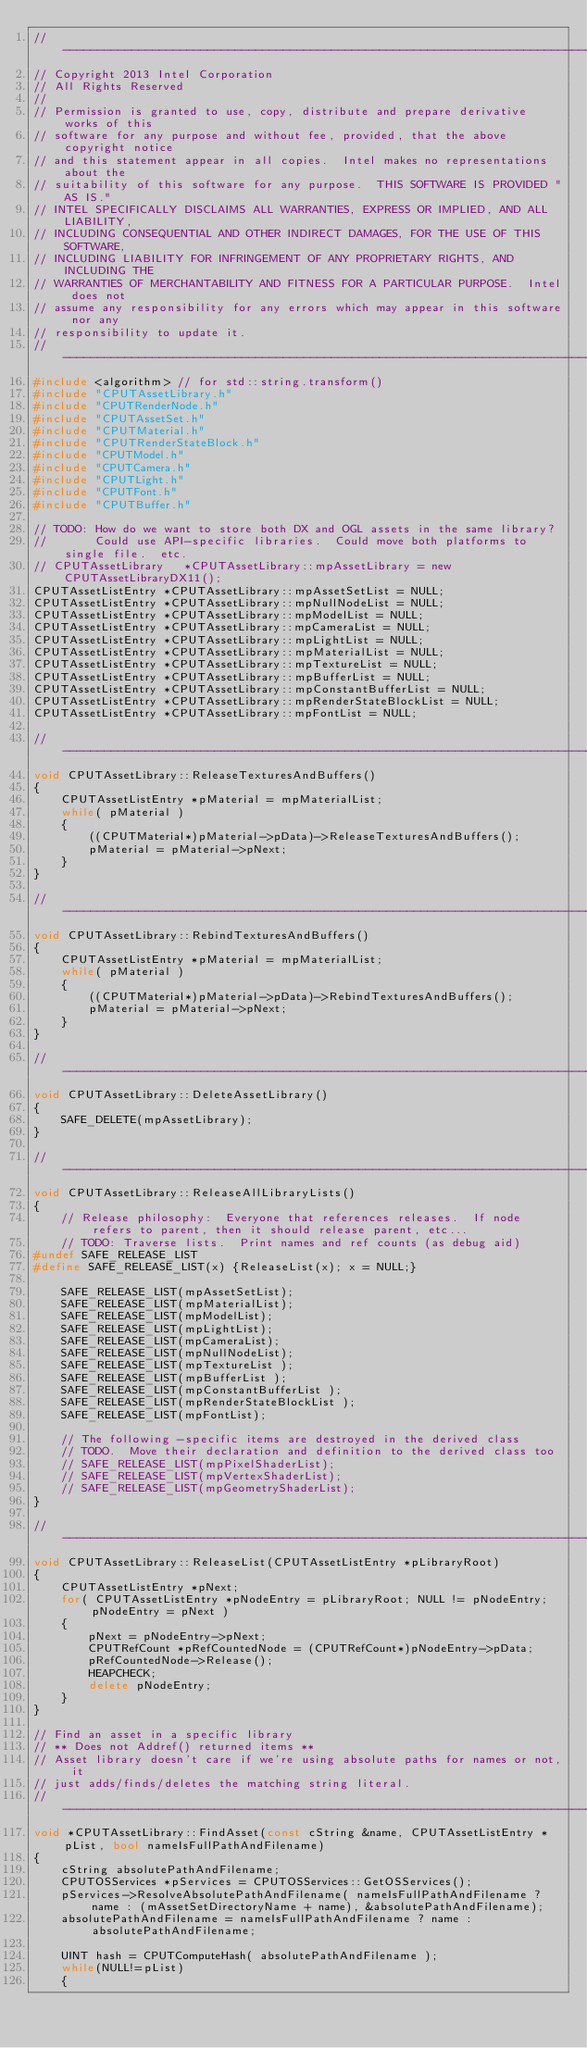<code> <loc_0><loc_0><loc_500><loc_500><_C++_>//--------------------------------------------------------------------------------------
// Copyright 2013 Intel Corporation
// All Rights Reserved
//
// Permission is granted to use, copy, distribute and prepare derivative works of this
// software for any purpose and without fee, provided, that the above copyright notice
// and this statement appear in all copies.  Intel makes no representations about the
// suitability of this software for any purpose.  THIS SOFTWARE IS PROVIDED "AS IS."
// INTEL SPECIFICALLY DISCLAIMS ALL WARRANTIES, EXPRESS OR IMPLIED, AND ALL LIABILITY,
// INCLUDING CONSEQUENTIAL AND OTHER INDIRECT DAMAGES, FOR THE USE OF THIS SOFTWARE,
// INCLUDING LIABILITY FOR INFRINGEMENT OF ANY PROPRIETARY RIGHTS, AND INCLUDING THE
// WARRANTIES OF MERCHANTABILITY AND FITNESS FOR A PARTICULAR PURPOSE.  Intel does not
// assume any responsibility for any errors which may appear in this software nor any
// responsibility to update it.
//--------------------------------------------------------------------------------------
#include <algorithm> // for std::string.transform()
#include "CPUTAssetLibrary.h"
#include "CPUTRenderNode.h"
#include "CPUTAssetSet.h"
#include "CPUTMaterial.h"
#include "CPUTRenderStateBlock.h"
#include "CPUTModel.h"
#include "CPUTCamera.h"
#include "CPUTLight.h"
#include "CPUTFont.h"
#include "CPUTBuffer.h"

// TODO: How do we want to store both DX and OGL assets in the same library?
//       Could use API-specific libraries.  Could move both platforms to single file.  etc.
// CPUTAssetLibrary   *CPUTAssetLibrary::mpAssetLibrary = new CPUTAssetLibraryDX11();
CPUTAssetListEntry *CPUTAssetLibrary::mpAssetSetList = NULL;
CPUTAssetListEntry *CPUTAssetLibrary::mpNullNodeList = NULL;
CPUTAssetListEntry *CPUTAssetLibrary::mpModelList = NULL;
CPUTAssetListEntry *CPUTAssetLibrary::mpCameraList = NULL;
CPUTAssetListEntry *CPUTAssetLibrary::mpLightList = NULL;
CPUTAssetListEntry *CPUTAssetLibrary::mpMaterialList = NULL;
CPUTAssetListEntry *CPUTAssetLibrary::mpTextureList = NULL;
CPUTAssetListEntry *CPUTAssetLibrary::mpBufferList = NULL;
CPUTAssetListEntry *CPUTAssetLibrary::mpConstantBufferList = NULL;
CPUTAssetListEntry *CPUTAssetLibrary::mpRenderStateBlockList = NULL;
CPUTAssetListEntry *CPUTAssetLibrary::mpFontList = NULL;

//-----------------------------------------------------------------------------
void CPUTAssetLibrary::ReleaseTexturesAndBuffers()
{
    CPUTAssetListEntry *pMaterial = mpMaterialList;
    while( pMaterial )
    {
        ((CPUTMaterial*)pMaterial->pData)->ReleaseTexturesAndBuffers();
        pMaterial = pMaterial->pNext;
    }
}

//-----------------------------------------------------------------------------
void CPUTAssetLibrary::RebindTexturesAndBuffers()
{
    CPUTAssetListEntry *pMaterial = mpMaterialList;
    while( pMaterial )
    {
        ((CPUTMaterial*)pMaterial->pData)->RebindTexturesAndBuffers();
        pMaterial = pMaterial->pNext;
    }
}

//-----------------------------------------------------------------------------
void CPUTAssetLibrary::DeleteAssetLibrary()
{
    SAFE_DELETE(mpAssetLibrary);
}

//-----------------------------------------------------------------------------
void CPUTAssetLibrary::ReleaseAllLibraryLists()
{
    // Release philosophy:  Everyone that references releases.  If node refers to parent, then it should release parent, etc...
    // TODO: Traverse lists.  Print names and ref counts (as debug aid)
#undef SAFE_RELEASE_LIST
#define SAFE_RELEASE_LIST(x) {ReleaseList(x); x = NULL;}

    SAFE_RELEASE_LIST(mpAssetSetList);
    SAFE_RELEASE_LIST(mpMaterialList);
    SAFE_RELEASE_LIST(mpModelList);
    SAFE_RELEASE_LIST(mpLightList);
    SAFE_RELEASE_LIST(mpCameraList);
    SAFE_RELEASE_LIST(mpNullNodeList);
    SAFE_RELEASE_LIST(mpTextureList );
    SAFE_RELEASE_LIST(mpBufferList );
    SAFE_RELEASE_LIST(mpConstantBufferList );
    SAFE_RELEASE_LIST(mpRenderStateBlockList );
    SAFE_RELEASE_LIST(mpFontList);

    // The following -specific items are destroyed in the derived class
    // TODO.  Move their declaration and definition to the derived class too
    // SAFE_RELEASE_LIST(mpPixelShaderList);
    // SAFE_RELEASE_LIST(mpVertexShaderList);
    // SAFE_RELEASE_LIST(mpGeometryShaderList);
}

//-----------------------------------------------------------------------------
void CPUTAssetLibrary::ReleaseList(CPUTAssetListEntry *pLibraryRoot)
{
    CPUTAssetListEntry *pNext;
    for( CPUTAssetListEntry *pNodeEntry = pLibraryRoot; NULL != pNodeEntry; pNodeEntry = pNext )
    {
        pNext = pNodeEntry->pNext;
        CPUTRefCount *pRefCountedNode = (CPUTRefCount*)pNodeEntry->pData;
        pRefCountedNode->Release();
        HEAPCHECK;
        delete pNodeEntry;
    }
}

// Find an asset in a specific library
// ** Does not Addref() returned items **
// Asset library doesn't care if we're using absolute paths for names or not, it
// just adds/finds/deletes the matching string literal.
//-----------------------------------------------------------------------------
void *CPUTAssetLibrary::FindAsset(const cString &name, CPUTAssetListEntry *pList, bool nameIsFullPathAndFilename)
{
    cString absolutePathAndFilename;
    CPUTOSServices *pServices = CPUTOSServices::GetOSServices();
    pServices->ResolveAbsolutePathAndFilename( nameIsFullPathAndFilename ? name : (mAssetSetDirectoryName + name), &absolutePathAndFilename);
    absolutePathAndFilename = nameIsFullPathAndFilename ? name : absolutePathAndFilename;

    UINT hash = CPUTComputeHash( absolutePathAndFilename );
    while(NULL!=pList)
    {</code> 